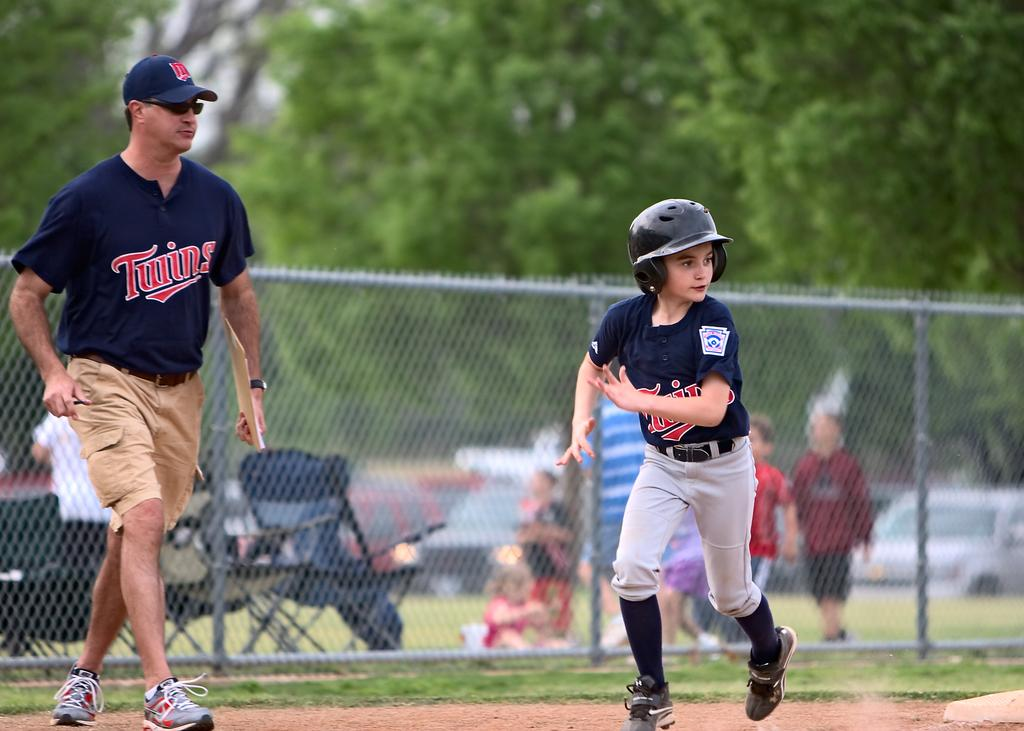<image>
Give a short and clear explanation of the subsequent image. A boy running wearing a baseball uniform with a man standing near by wearing a Twins jersey. 